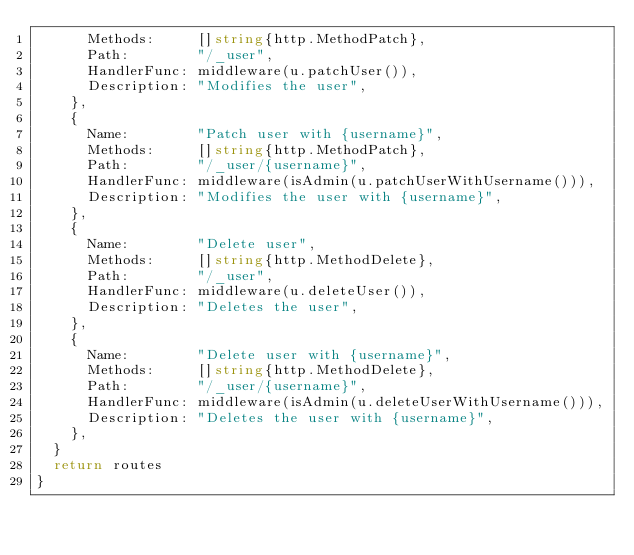<code> <loc_0><loc_0><loc_500><loc_500><_Go_>			Methods:     []string{http.MethodPatch},
			Path:        "/_user",
			HandlerFunc: middleware(u.patchUser()),
			Description: "Modifies the user",
		},
		{
			Name:        "Patch user with {username}",
			Methods:     []string{http.MethodPatch},
			Path:        "/_user/{username}",
			HandlerFunc: middleware(isAdmin(u.patchUserWithUsername())),
			Description: "Modifies the user with {username}",
		},
		{
			Name:        "Delete user",
			Methods:     []string{http.MethodDelete},
			Path:        "/_user",
			HandlerFunc: middleware(u.deleteUser()),
			Description: "Deletes the user",
		},
		{
			Name:        "Delete user with {username}",
			Methods:     []string{http.MethodDelete},
			Path:        "/_user/{username}",
			HandlerFunc: middleware(isAdmin(u.deleteUserWithUsername())),
			Description: "Deletes the user with {username}",
		},
	}
	return routes
}
</code> 